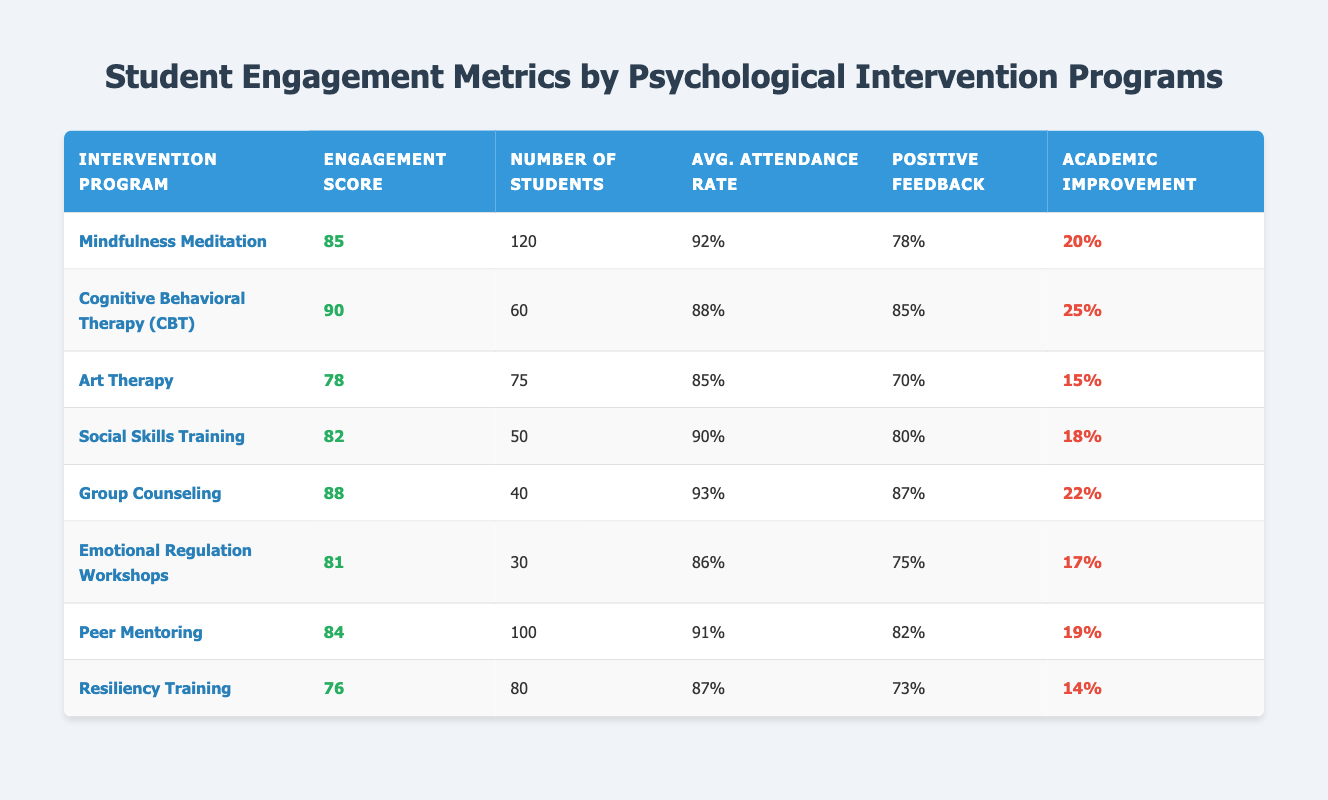What is the engagement score for the Cognitive Behavioral Therapy program? The engagement score for Cognitive Behavioral Therapy (CBT) is clearly stated in the table, which shows it as 90.
Answer: 90 How many students participated in the Art Therapy program? The number of students who participated in the Art Therapy program is listed in the table as 75.
Answer: 75 What is the average attendance rate for the Group Counseling program? The average attendance rate for the Group Counseling program is given in the table as 93%.
Answer: 93% Which intervention program had the highest positive feedback percentage? By comparing the positive feedback percentages in the table, Cognitive Behavioral Therapy (CBT) had the highest at 85%.
Answer: 85% What is the difference in academic improvement percentage between Mindfulness Meditation and Social Skills Training? The academic improvement percentage for Mindfulness Meditation is 20% and for Social Skills Training is 18%. The difference is 20% - 18% = 2%.
Answer: 2% Which program has the lowest engagement score and what is it? By examining the engagement scores, Resiliency Training has the lowest score at 76.
Answer: 76 Is the average attendance rate for Peer Mentoring higher than that of Emotional Regulation Workshops? The average attendance rate for Peer Mentoring is 91% and for Emotional Regulation Workshops is 86%. Yes, 91% is higher than 86%.
Answer: Yes What is the combined number of students in the Mindfulness Meditation and Group Counseling programs? The combined number of students is obtained by adding the number of students in Mindfulness Meditation (120) and Group Counseling (40): 120 + 40 = 160.
Answer: 160 Which intervention program shows an academic improvement percentage less than 15%? By checking all academic improvement percentages, Art Therapy (15%) and Resiliency Training (14%) are equal to or less than 15%. Resiliency Training shows less than 15%.
Answer: Resiliency Training If we consider the two programs with the highest engagement scores, what is the average engagement score of those two programs? The two highest engagement scores are 90 (CBT) and 88 (Group Counseling). To find the average: (90 + 88) / 2 = 89.
Answer: 89 